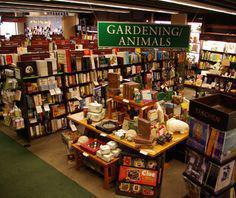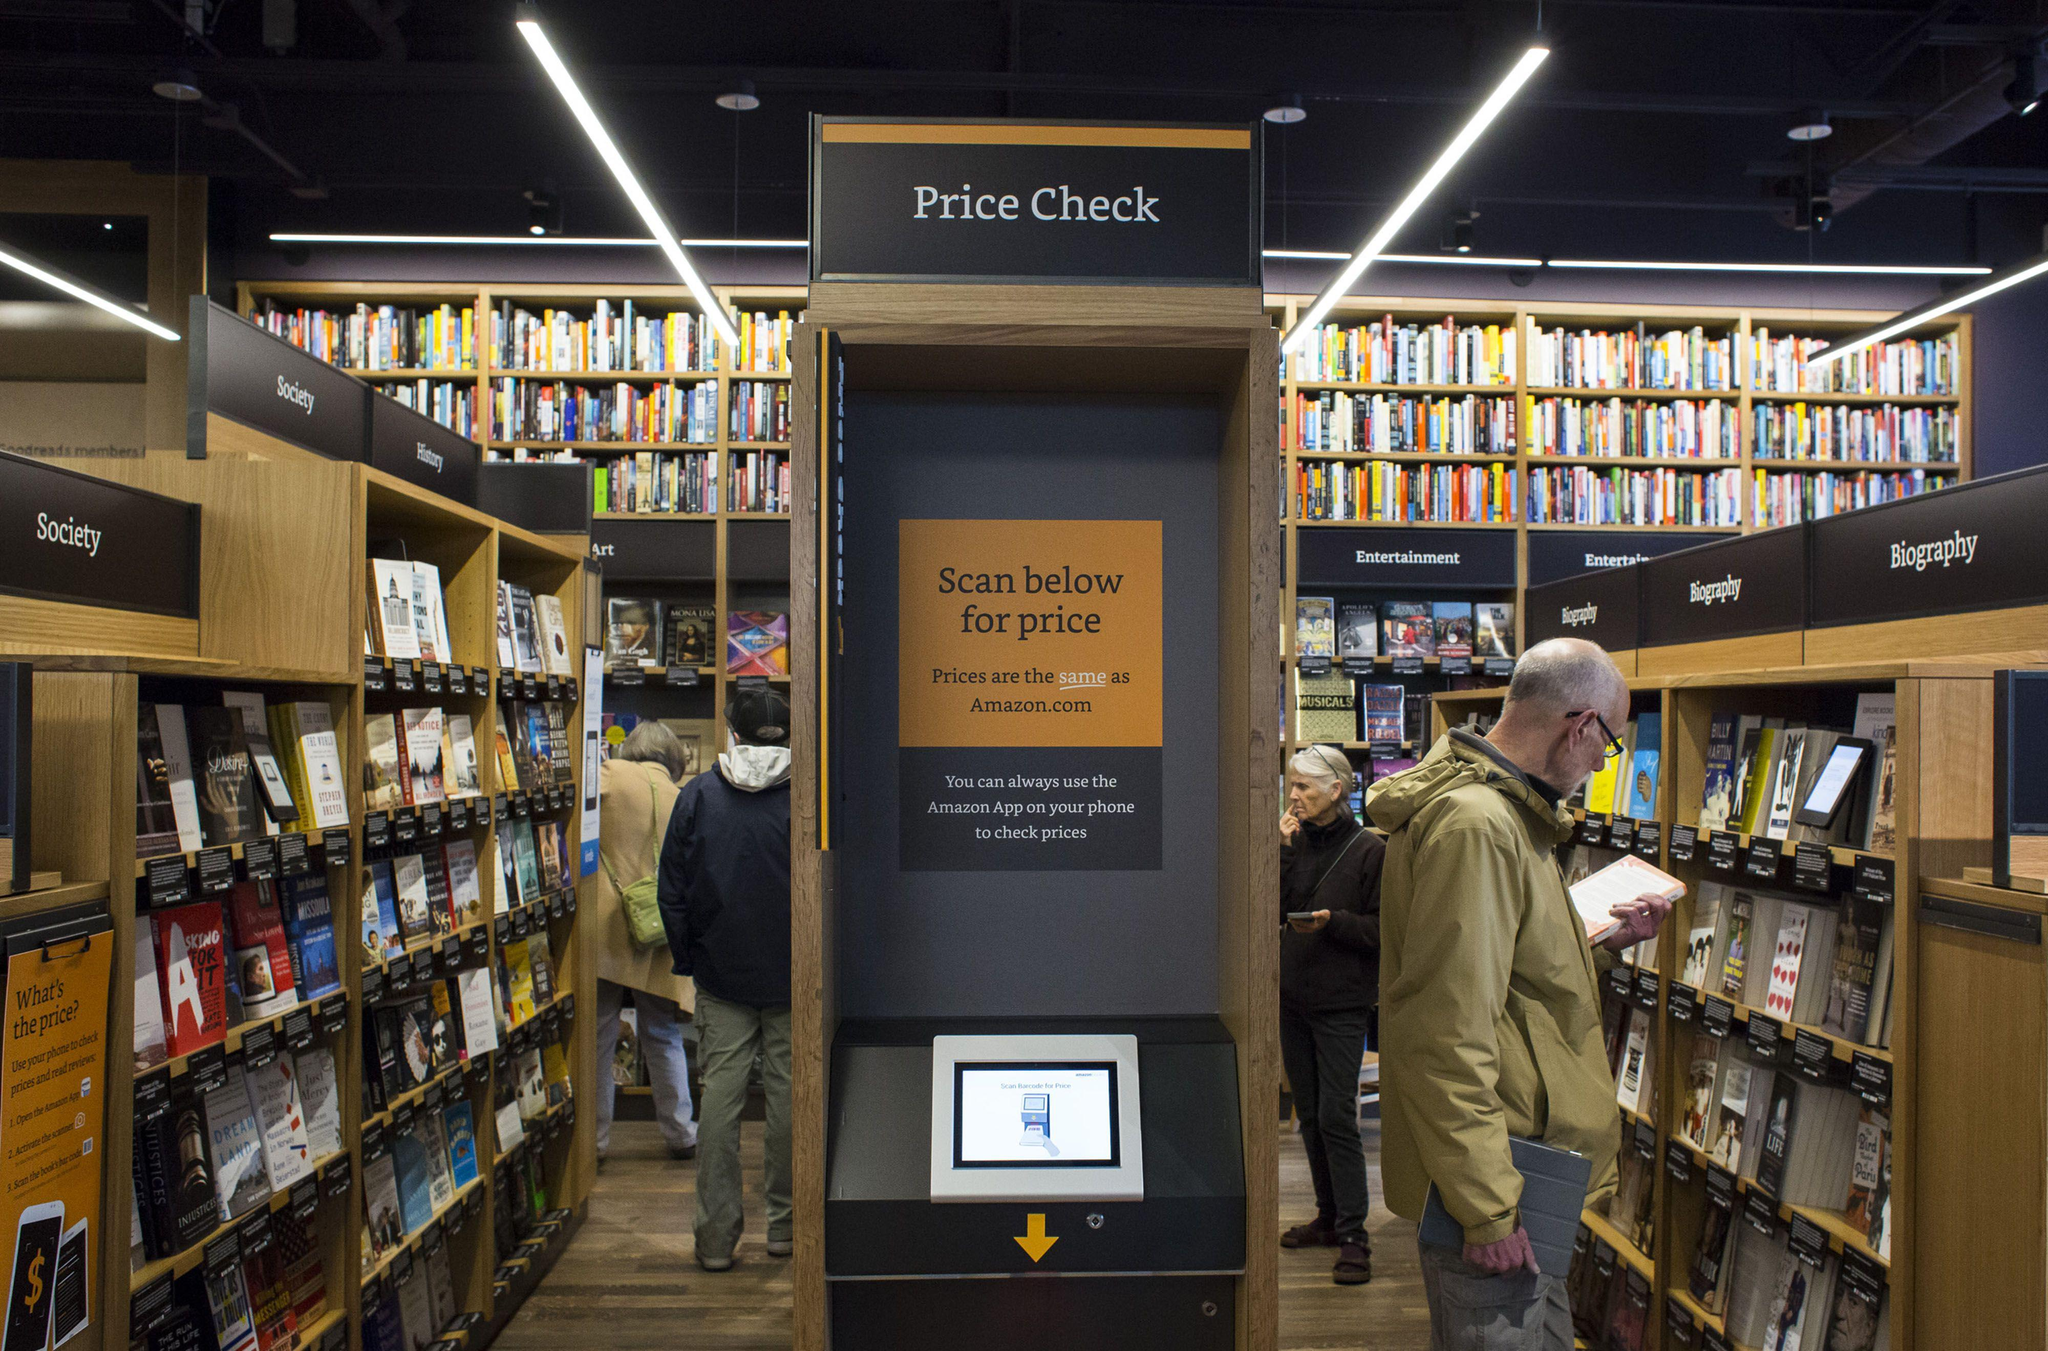The first image is the image on the left, the second image is the image on the right. Evaluate the accuracy of this statement regarding the images: "One image shows an upright furry cartoonish creature in front of items displayed for sale.". Is it true? Answer yes or no. No. The first image is the image on the left, the second image is the image on the right. Assess this claim about the two images: "One of the images features a large stuffed animal/character from a popular book.". Correct or not? Answer yes or no. No. 